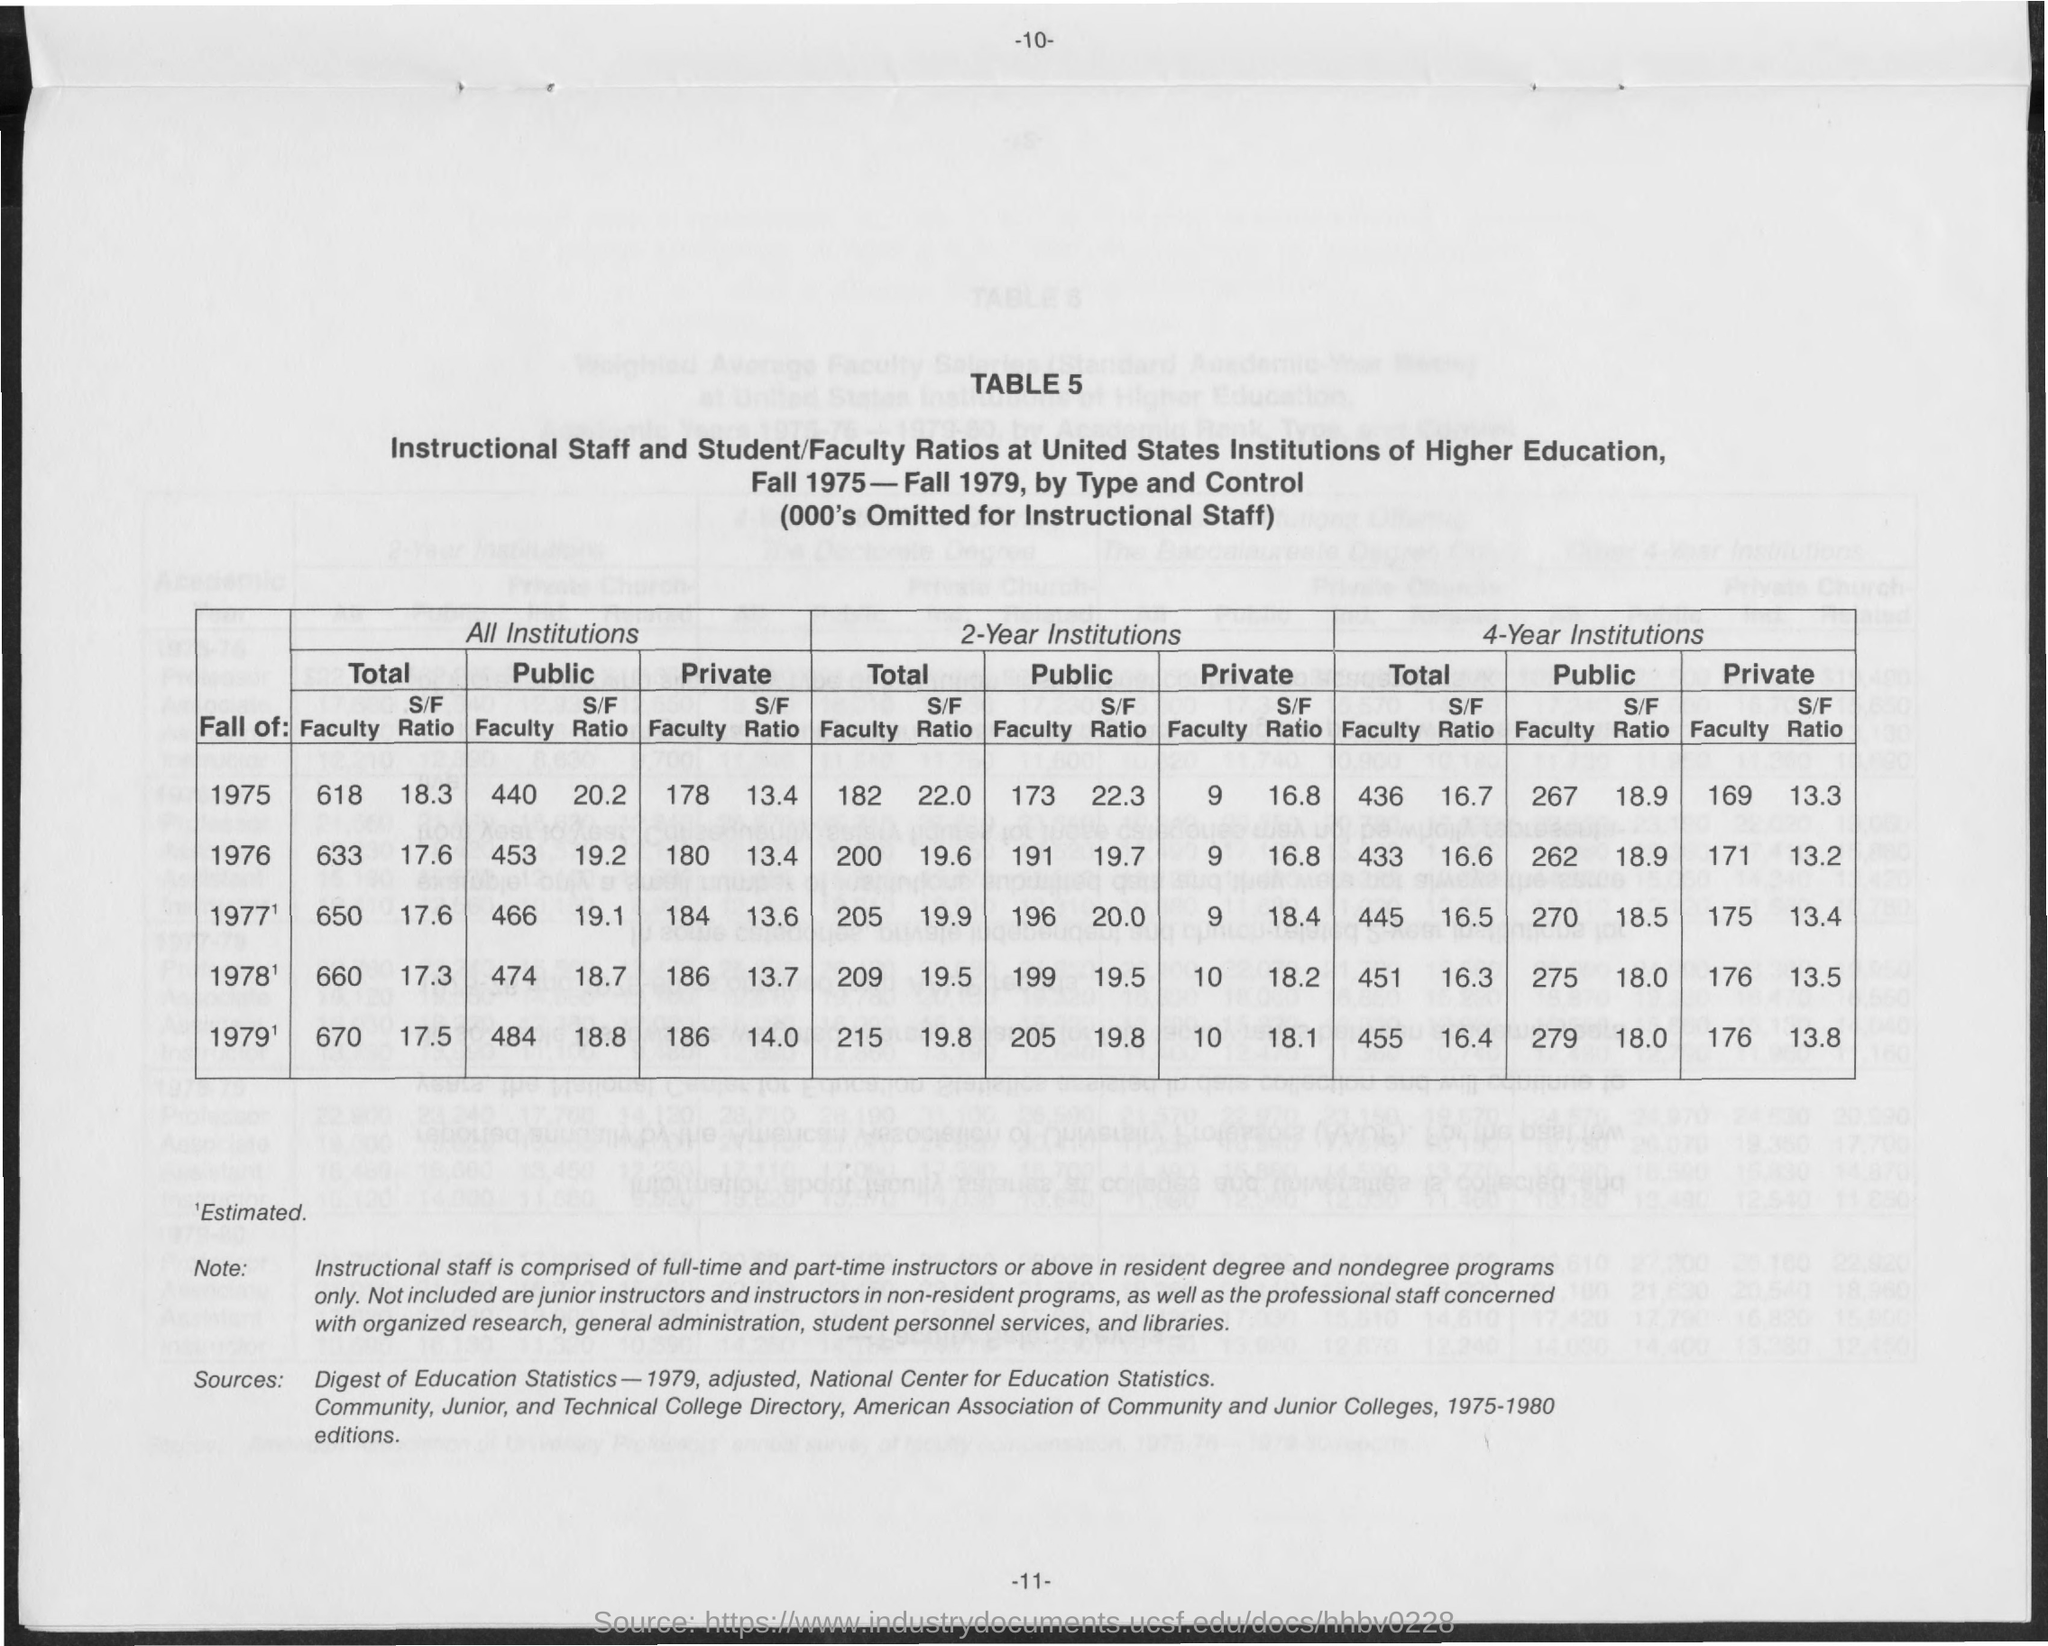Indicate a few pertinent items in this graphic. The page number is 11. 